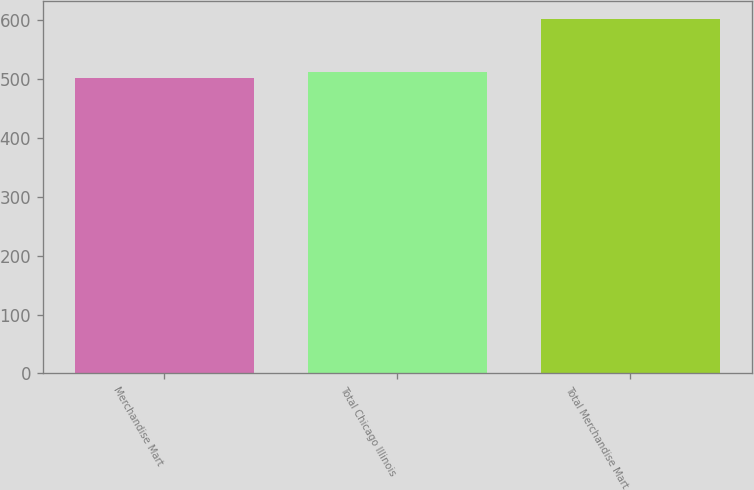Convert chart to OTSL. <chart><loc_0><loc_0><loc_500><loc_500><bar_chart><fcel>Merchandise Mart<fcel>Total Chicago Illinois<fcel>Total Merchandise Mart<nl><fcel>502<fcel>512.1<fcel>603<nl></chart> 